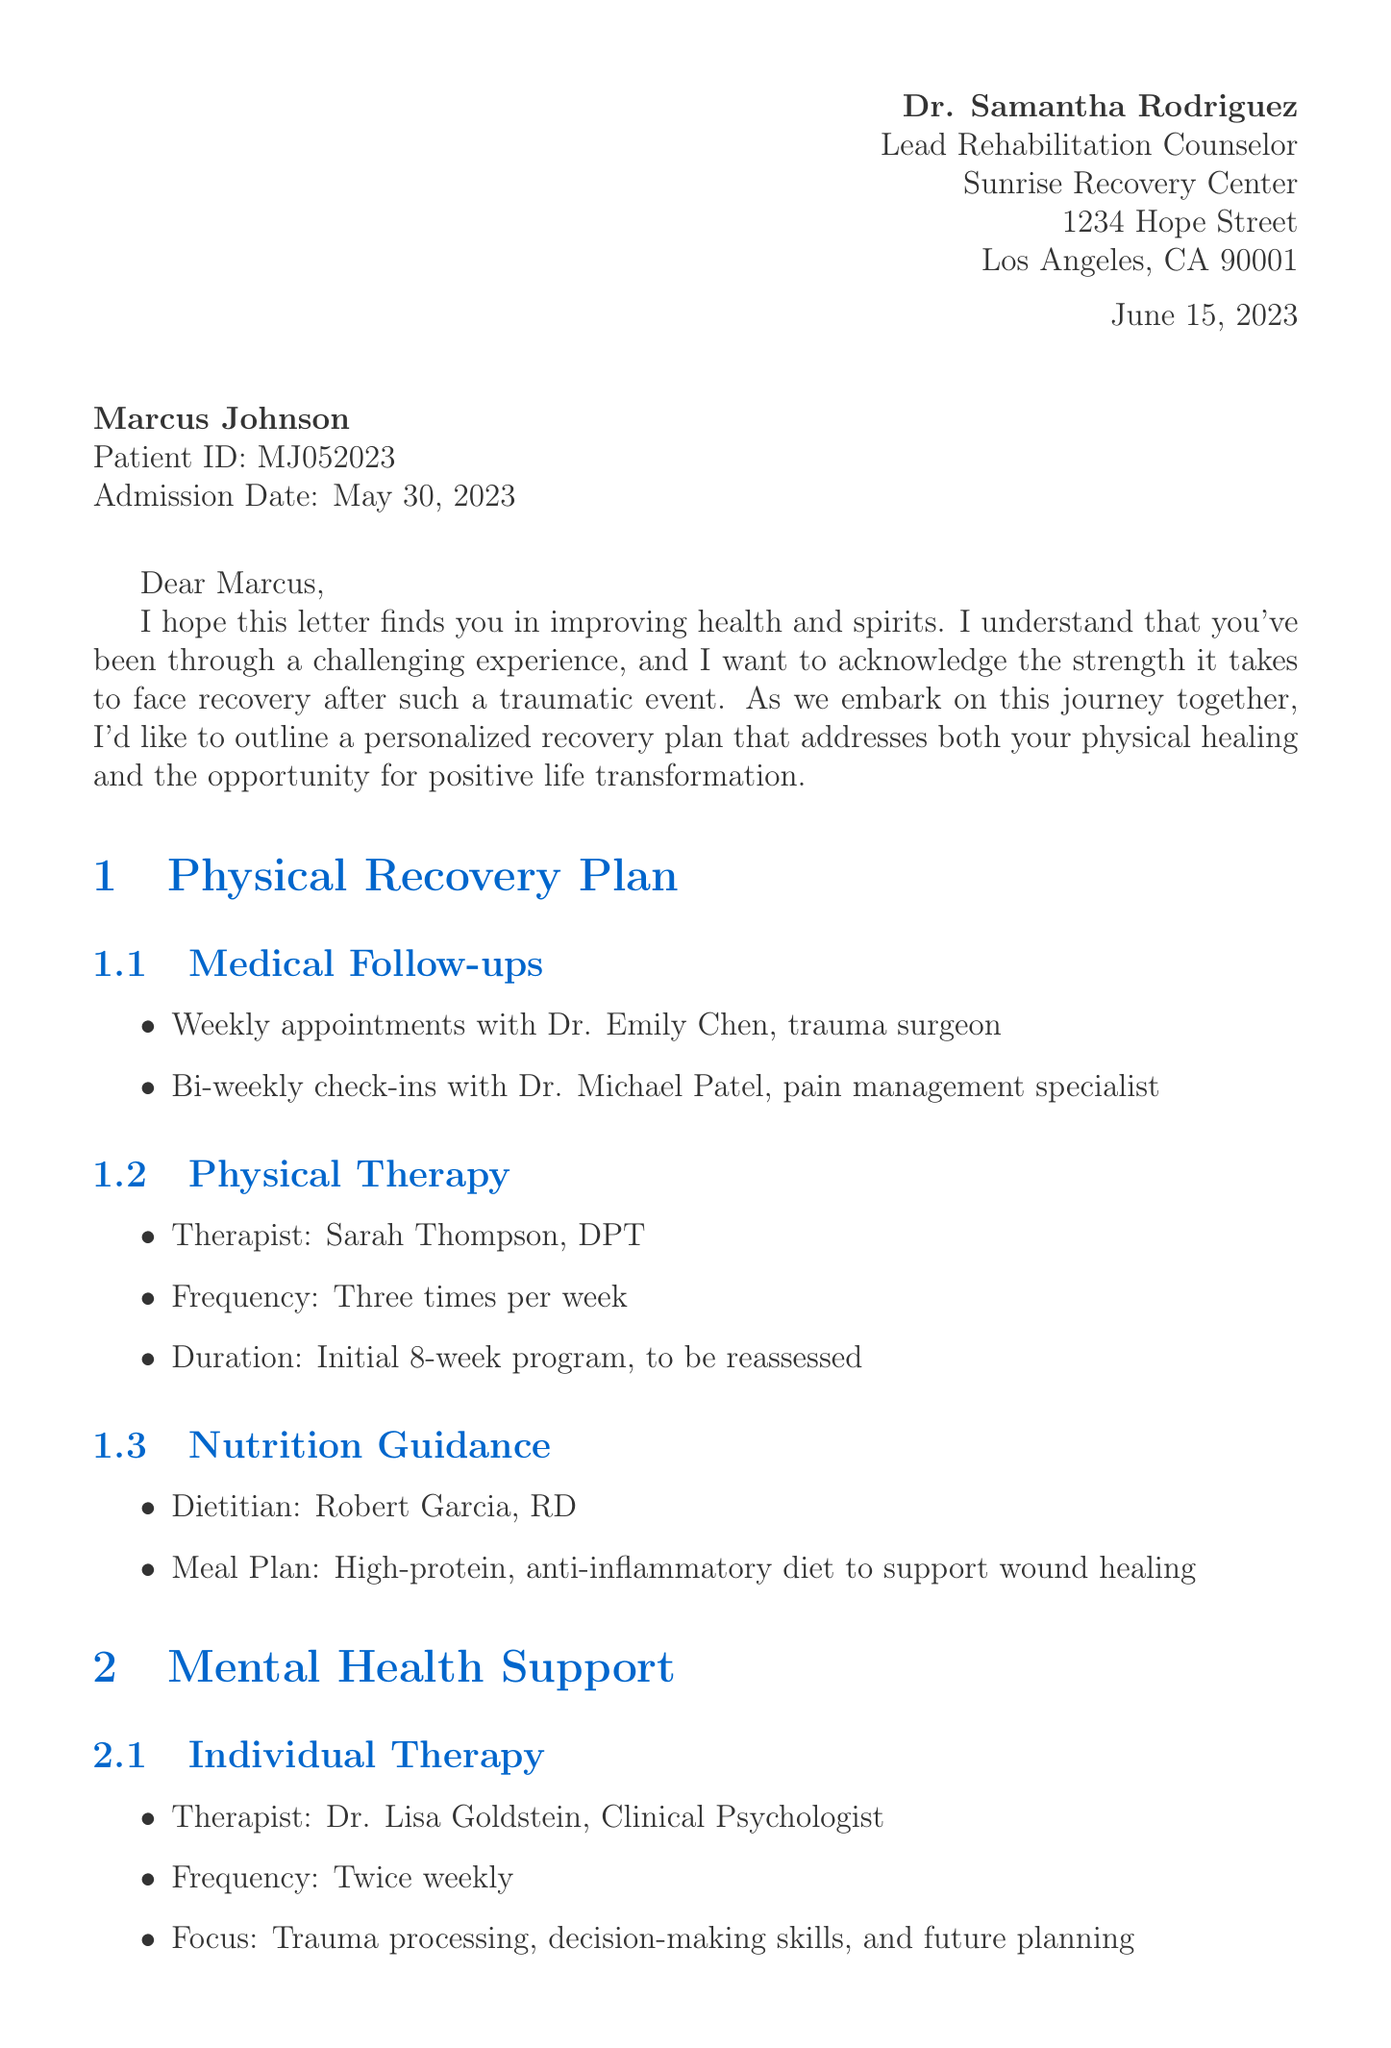What is the name of the lead rehabilitation counselor? The lead rehabilitation counselor is a specific individual mentioned in the document responsible for the patient’s recovery plan.
Answer: Dr. Samantha Rodriguez What is Marcus Johnson's age? The document explicitly states the patient's age, which can be found in the patient information section.
Answer: 22 When was the admission date? The admission date is a key detail about the patient's history and treatment commencement outlined in the patient information section.
Answer: May 30, 2023 How often will Marcus attend physical therapy? The frequency of physical therapy sessions is detailed in the physical recovery plan section.
Answer: Three times per week What is the focus of individual therapy? The focus area of therapy sessions is outlined as it relates to the patient's mental health support.
Answer: Trauma processing, decision-making skills, and future planning What kind of diet is recommended for Marcus? The nutrition guidance section specifies the type of diet that is prescribed to aid in recovery.
Answer: High-protein, anti-inflammatory diet What is the duration of the GED preparation course? This information is part of the education and skill-building section, indicating how long the course runs.
Answer: 12-week program Who coordinates the mentorship program? The name of the coordinator for the mentorship program is mentioned, emphasizing support for community reintegration.
Answer: Marcus Greene What phone number is provided for crisis support? The document includes a contact number for crisis support, which is essential for immediate assistance resources.
Answer: 1-800-RECOVERY 